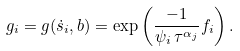<formula> <loc_0><loc_0><loc_500><loc_500>g _ { i } = g ( \dot { s } _ { i } , b ) = \exp \left ( \frac { - 1 } { \psi _ { i } \, \tau ^ { \alpha _ { j } } } f _ { i } \right ) .</formula> 